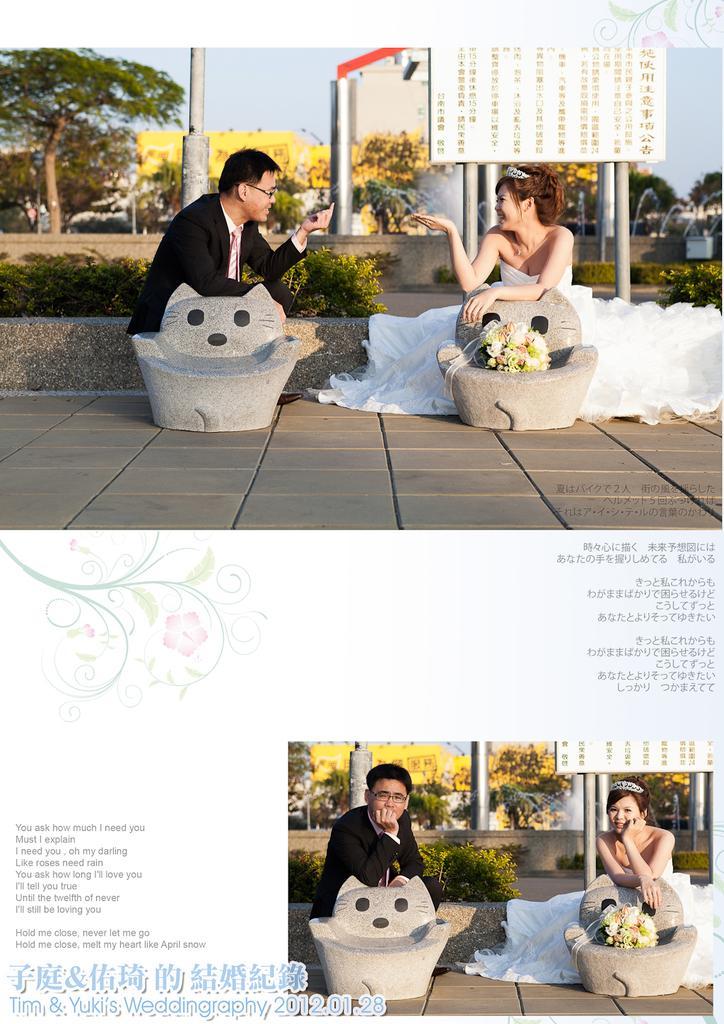How would you summarize this image in a sentence or two? In this image I can see replica of two pictures visible in the picture I can see two persons and two chairs and on the chair I can see flower boo key and woman wearing a white color dress and man wearing a black color dress and poles and trees and the sky visible at the top ,at the bottom I can see text. 